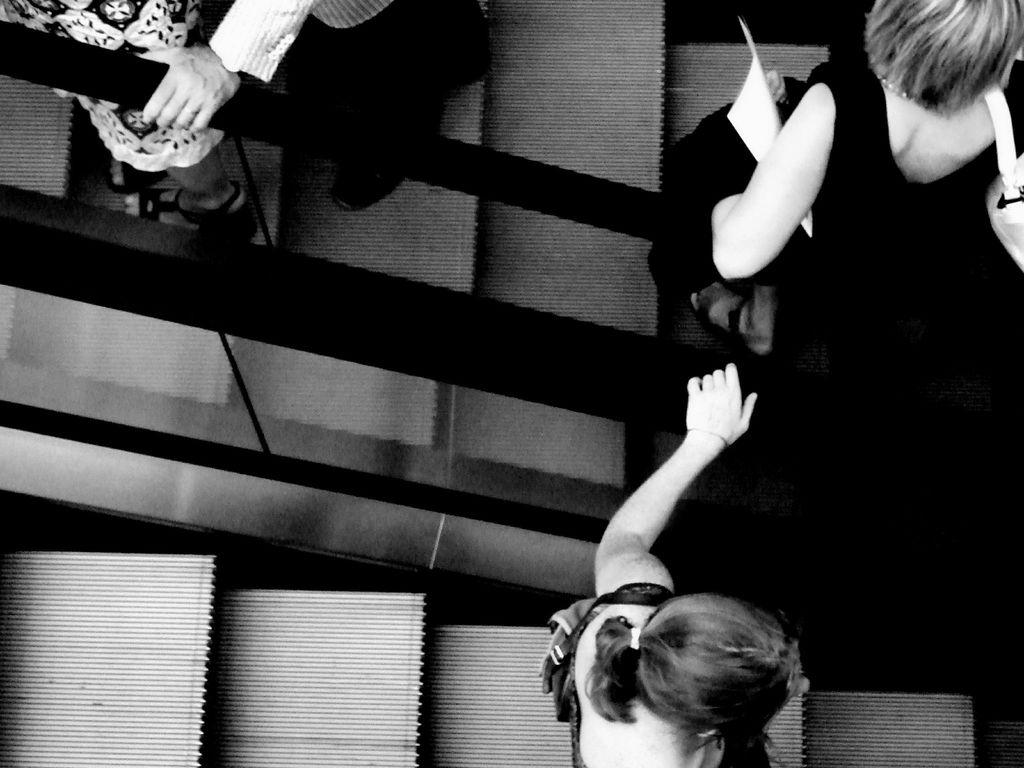How many people are in the image? There are four persons in the image. Can you describe the clothing of one of the individuals? There is a woman wearing a black dress. What type of architectural feature is visible at the bottom of the image? There appears to be an escalator at the bottom of the image. What type of holiday is being celebrated in the image? There is no indication of a holiday being celebrated in the image. How does the escalator provide support to the people in the image? The escalator is not providing support to the people in the image; it is a stationary architectural feature. 